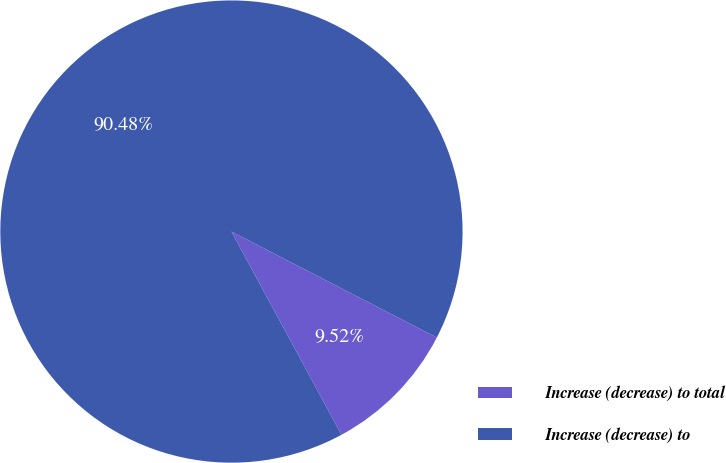Convert chart to OTSL. <chart><loc_0><loc_0><loc_500><loc_500><pie_chart><fcel>Increase (decrease) to total<fcel>Increase (decrease) to<nl><fcel>9.52%<fcel>90.48%<nl></chart> 